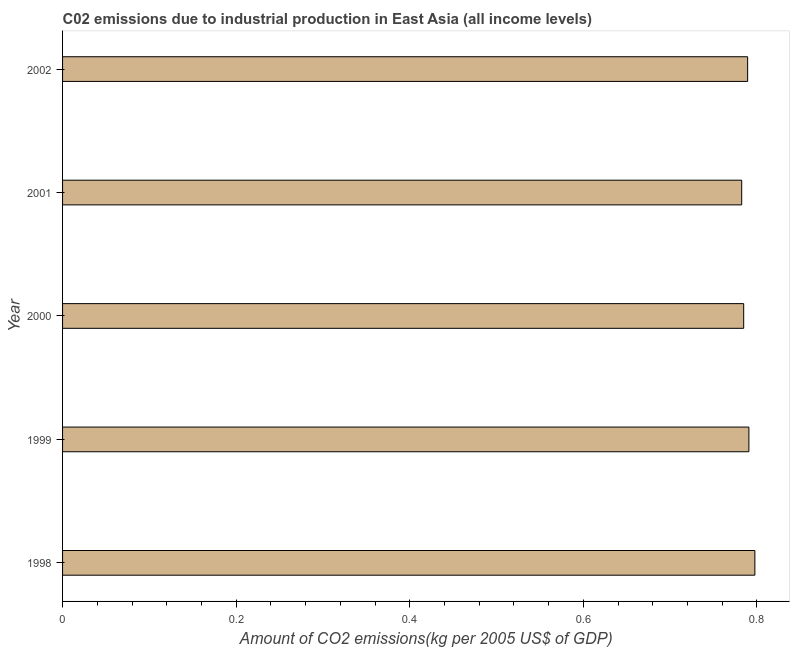What is the title of the graph?
Provide a succinct answer. C02 emissions due to industrial production in East Asia (all income levels). What is the label or title of the X-axis?
Offer a terse response. Amount of CO2 emissions(kg per 2005 US$ of GDP). What is the amount of co2 emissions in 1998?
Offer a terse response. 0.8. Across all years, what is the maximum amount of co2 emissions?
Your answer should be compact. 0.8. Across all years, what is the minimum amount of co2 emissions?
Provide a short and direct response. 0.78. In which year was the amount of co2 emissions minimum?
Offer a terse response. 2001. What is the sum of the amount of co2 emissions?
Give a very brief answer. 3.94. What is the difference between the amount of co2 emissions in 2001 and 2002?
Your answer should be very brief. -0.01. What is the average amount of co2 emissions per year?
Provide a succinct answer. 0.79. What is the median amount of co2 emissions?
Your answer should be compact. 0.79. Do a majority of the years between 2002 and 2000 (inclusive) have amount of co2 emissions greater than 0.2 kg per 2005 US$ of GDP?
Offer a terse response. Yes. What is the difference between the highest and the second highest amount of co2 emissions?
Keep it short and to the point. 0.01. How many years are there in the graph?
Provide a short and direct response. 5. What is the Amount of CO2 emissions(kg per 2005 US$ of GDP) of 1998?
Make the answer very short. 0.8. What is the Amount of CO2 emissions(kg per 2005 US$ of GDP) in 1999?
Offer a very short reply. 0.79. What is the Amount of CO2 emissions(kg per 2005 US$ of GDP) in 2000?
Ensure brevity in your answer.  0.78. What is the Amount of CO2 emissions(kg per 2005 US$ of GDP) of 2001?
Offer a very short reply. 0.78. What is the Amount of CO2 emissions(kg per 2005 US$ of GDP) in 2002?
Make the answer very short. 0.79. What is the difference between the Amount of CO2 emissions(kg per 2005 US$ of GDP) in 1998 and 1999?
Offer a very short reply. 0.01. What is the difference between the Amount of CO2 emissions(kg per 2005 US$ of GDP) in 1998 and 2000?
Your response must be concise. 0.01. What is the difference between the Amount of CO2 emissions(kg per 2005 US$ of GDP) in 1998 and 2001?
Your answer should be compact. 0.02. What is the difference between the Amount of CO2 emissions(kg per 2005 US$ of GDP) in 1998 and 2002?
Provide a succinct answer. 0.01. What is the difference between the Amount of CO2 emissions(kg per 2005 US$ of GDP) in 1999 and 2000?
Ensure brevity in your answer.  0.01. What is the difference between the Amount of CO2 emissions(kg per 2005 US$ of GDP) in 1999 and 2001?
Offer a terse response. 0.01. What is the difference between the Amount of CO2 emissions(kg per 2005 US$ of GDP) in 1999 and 2002?
Offer a terse response. 0. What is the difference between the Amount of CO2 emissions(kg per 2005 US$ of GDP) in 2000 and 2001?
Your answer should be very brief. 0. What is the difference between the Amount of CO2 emissions(kg per 2005 US$ of GDP) in 2000 and 2002?
Your response must be concise. -0. What is the difference between the Amount of CO2 emissions(kg per 2005 US$ of GDP) in 2001 and 2002?
Provide a short and direct response. -0.01. What is the ratio of the Amount of CO2 emissions(kg per 2005 US$ of GDP) in 1998 to that in 2002?
Your answer should be very brief. 1.01. What is the ratio of the Amount of CO2 emissions(kg per 2005 US$ of GDP) in 1999 to that in 2002?
Give a very brief answer. 1. What is the ratio of the Amount of CO2 emissions(kg per 2005 US$ of GDP) in 2000 to that in 2002?
Provide a succinct answer. 0.99. 